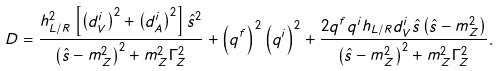<formula> <loc_0><loc_0><loc_500><loc_500>D = \frac { h _ { L / R } ^ { 2 } \left [ \left ( d _ { V } ^ { i } \right ) ^ { 2 } + \left ( d _ { A } ^ { i } \right ) ^ { 2 } \right ] \hat { s } ^ { 2 } } { \left ( \hat { s } - m _ { Z } ^ { 2 } \right ) ^ { 2 } + m _ { Z } ^ { 2 } \Gamma _ { Z } ^ { 2 } } + \left ( q ^ { f } \right ) ^ { 2 } \left ( q ^ { i } \right ) ^ { 2 } + \frac { 2 q ^ { f } q ^ { i } h _ { L / R } d _ { V } ^ { i } \hat { s } \left ( \hat { s } - m _ { Z } ^ { 2 } \right ) } { \left ( \hat { s } - m _ { Z } ^ { 2 } \right ) ^ { 2 } + m _ { Z } ^ { 2 } \Gamma _ { Z } ^ { 2 } } .</formula> 